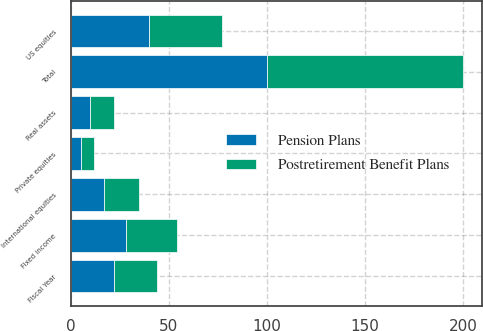Convert chart. <chart><loc_0><loc_0><loc_500><loc_500><stacked_bar_chart><ecel><fcel>Fiscal Year<fcel>US equities<fcel>International equities<fcel>Private equities<fcel>Fixed income<fcel>Real assets<fcel>Total<nl><fcel>Postretirement Benefit Plans<fcel>22<fcel>37<fcel>18<fcel>7<fcel>26<fcel>12<fcel>100<nl><fcel>Pension Plans<fcel>22<fcel>40<fcel>17<fcel>5<fcel>28<fcel>10<fcel>100<nl></chart> 